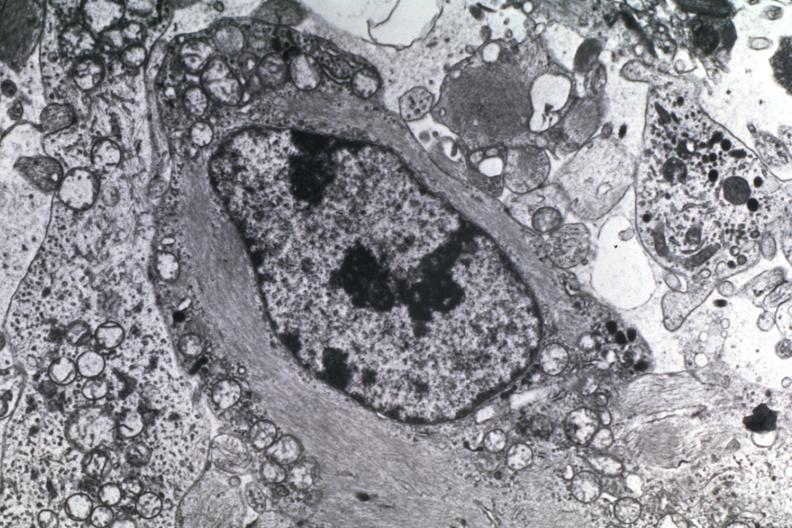s side present?
Answer the question using a single word or phrase. No 